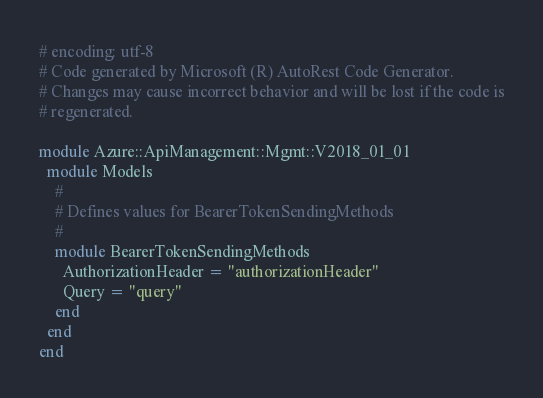<code> <loc_0><loc_0><loc_500><loc_500><_Ruby_># encoding: utf-8
# Code generated by Microsoft (R) AutoRest Code Generator.
# Changes may cause incorrect behavior and will be lost if the code is
# regenerated.

module Azure::ApiManagement::Mgmt::V2018_01_01
  module Models
    #
    # Defines values for BearerTokenSendingMethods
    #
    module BearerTokenSendingMethods
      AuthorizationHeader = "authorizationHeader"
      Query = "query"
    end
  end
end
</code> 